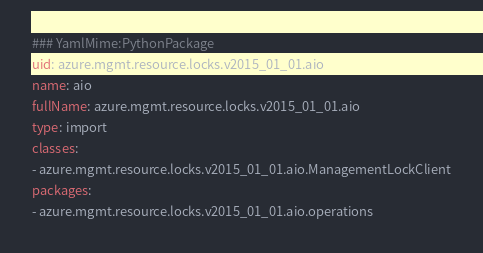Convert code to text. <code><loc_0><loc_0><loc_500><loc_500><_YAML_>### YamlMime:PythonPackage
uid: azure.mgmt.resource.locks.v2015_01_01.aio
name: aio
fullName: azure.mgmt.resource.locks.v2015_01_01.aio
type: import
classes:
- azure.mgmt.resource.locks.v2015_01_01.aio.ManagementLockClient
packages:
- azure.mgmt.resource.locks.v2015_01_01.aio.operations
</code> 